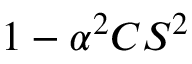Convert formula to latex. <formula><loc_0><loc_0><loc_500><loc_500>1 - \alpha ^ { 2 } C S ^ { 2 }</formula> 